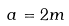<formula> <loc_0><loc_0><loc_500><loc_500>a = 2 m</formula> 